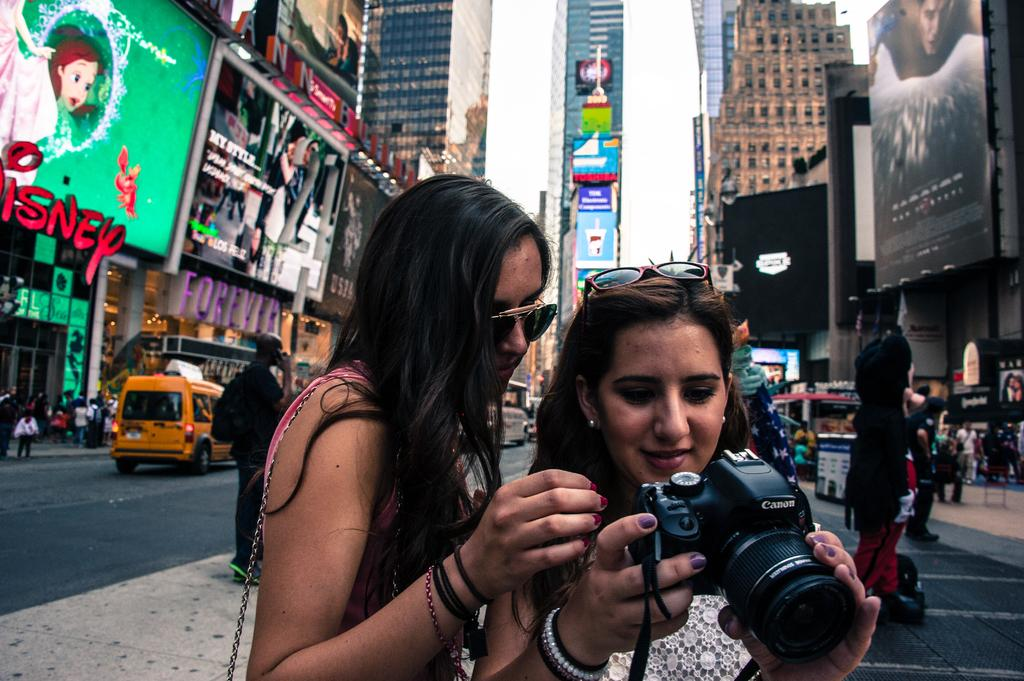<image>
Render a clear and concise summary of the photo. A girl holds a Canon camera in a busy city area. 